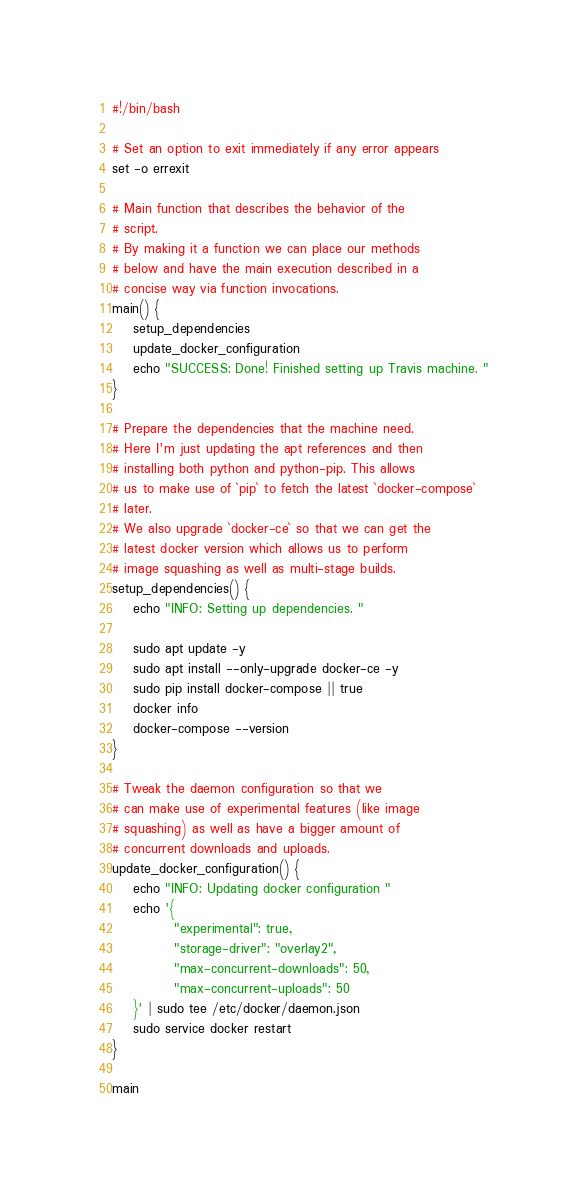Convert code to text. <code><loc_0><loc_0><loc_500><loc_500><_Bash_>#!/bin/bash

# Set an option to exit immediately if any error appears
set -o errexit

# Main function that describes the behavior of the
# script.
# By making it a function we can place our methods
# below and have the main execution described in a
# concise way via function invocations.
main() {
    setup_dependencies
    update_docker_configuration
    echo "SUCCESS: Done! Finished setting up Travis machine. "
}

# Prepare the dependencies that the machine need.
# Here I'm just updating the apt references and then
# installing both python and python-pip. This allows
# us to make use of `pip` to fetch the latest `docker-compose`
# later.
# We also upgrade `docker-ce` so that we can get the
# latest docker version which allows us to perform
# image squashing as well as multi-stage builds.
setup_dependencies() {
    echo "INFO: Setting up dependencies. "
    
    sudo apt update -y
    sudo apt install --only-upgrade docker-ce -y
    sudo pip install docker-compose || true
    docker info
    docker-compose --version
}

# Tweak the daemon configuration so that we
# can make use of experimental features (like image
# squashing) as well as have a bigger amount of
# concurrent downloads and uploads.
update_docker_configuration() {
    echo "INFO: Updating docker configuration "
    echo '{
            "experimental": true,
            "storage-driver": "overlay2",
            "max-concurrent-downloads": 50,
            "max-concurrent-uploads": 50
    }' | sudo tee /etc/docker/daemon.json
    sudo service docker restart
}

main</code> 